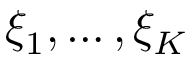<formula> <loc_0><loc_0><loc_500><loc_500>\xi _ { 1 } , \dots , \xi _ { K }</formula> 